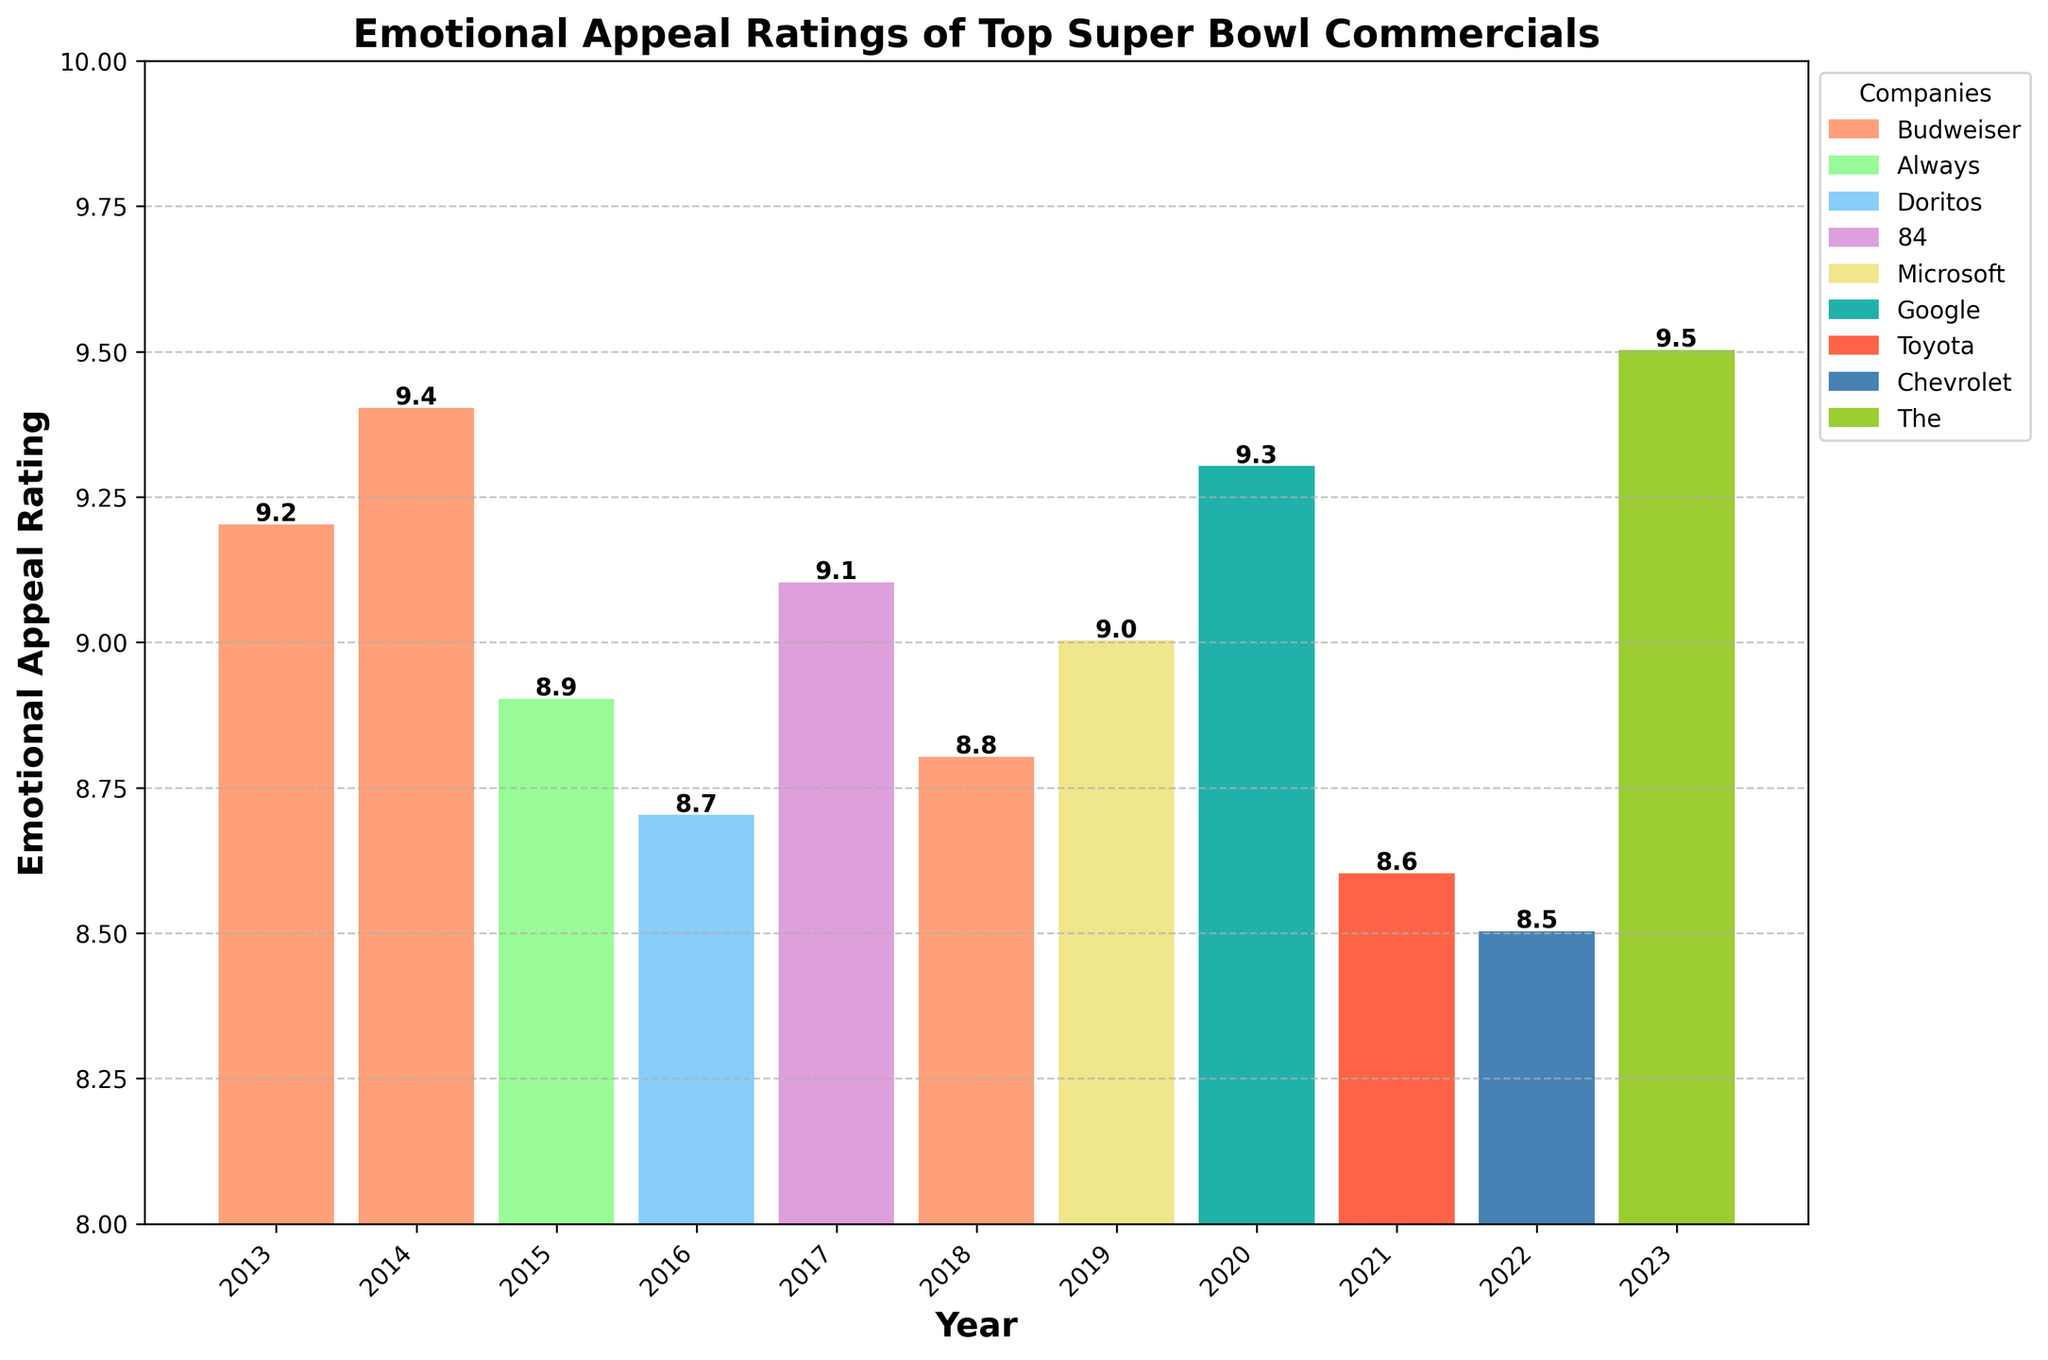Which company had the highest emotional appeal rating in the past decade? The company with the highest emotional appeal rating is The Farmer's Dog in 2023 with a rating of 9.5.
Answer: The Farmer's Dog What is the average emotional appeal rating of Budweiser commercials? Budweiser commercials were aired in 2013, 2014, and 2018 with ratings of 9.2, 9.4, and 8.8. The average is calculated as (9.2 + 9.4 + 8.8) / 3 = 9.13
Answer: 9.13 Which year had the lowest emotional appeal rating and what was the rating? The year 2022 had the lowest emotional appeal rating with Chevrolet "New Generation" achieving a rating of 8.5.
Answer: 2022, 8.5 Compare the emotional appeal ratings of commercials in 2017 and 2020. Which one was rated higher and by how much? In 2017, the 84 Lumber "The Journey" commercial had a rating of 9.1, whereas, in 2020, Google "Loretta" had a rating of 9.3. Google "Loretta" was rated higher by 0.2 points.
Answer: Google "Loretta" by 0.2 What is the total emotional appeal rating of the commercials between 2018 and 2022 (inclusive)? The ratings for the years 2018 to 2022 are 8.8, 9.0, 9.3, 8.6, and 8.5. The total is 8.8 + 9.0 + 9.3 + 8.6 + 8.5 = 44.2
Answer: 44.2 Identify the company that appears most frequently in the chart and state how many times it appears. Budweiser appears most frequently in the chart, with three commercials in 2013, 2014, and 2018.
Answer: Budweiser, 3 times Which companies from the chart used emotional appeal in their commercials consistently over multiple years? From the chart, only Budweiser used emotional appeal in their commercials consistently across multiple years (2013, 2014, and 2018).
Answer: Budweiser Compare the emotional appeal ratings of the commercials from the years 2015 and 2023. Which one had a higher rating, and by what amount? The 2015 Always "Like a Girl" commercial had a rating of 8.9, while the 2023 The Farmer's Dog "Forever" had a rating of 9.5. The Farmer's Dog "Forever" was rated higher by 0.6 points.
Answer: The Farmer's Dog "Forever" by 0.6 What can be inferred about the trend in emotional appeal ratings of Super Bowl commercials from 2013 to 2023? The trend in emotional appeal ratings of top-performing Super Bowl commercials from 2013 to 2023 shows generally high ratings, with a few fluctuations but consistently remaining above 8.5.
Answer: Consistent high ratings What are some key observations you can make regarding the variation in emotional appeal ratings among different companies' commercials? Some key observations are that ratings vary but most top-performing commercials, irrespective of the company, have ratings above 8.5, showing high emotional appeal consistency. Budweiser appears frequently with high ratings, and The Farmer's Dog has the highest rating.
Answer: High but varying ratings above 8.5, Budweiser frequent, The Farmer's Dog highest 